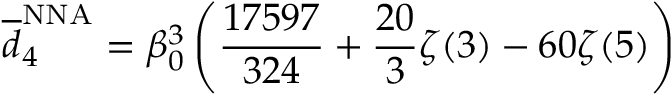<formula> <loc_0><loc_0><loc_500><loc_500>\overline { d } _ { 4 } ^ { N N A } = \beta _ { 0 } ^ { 3 } \left ( { \frac { 1 7 5 9 7 } { 3 2 4 } } + { \frac { 2 0 } { 3 } } \zeta ( 3 ) - 6 0 \zeta ( 5 ) \right )</formula> 